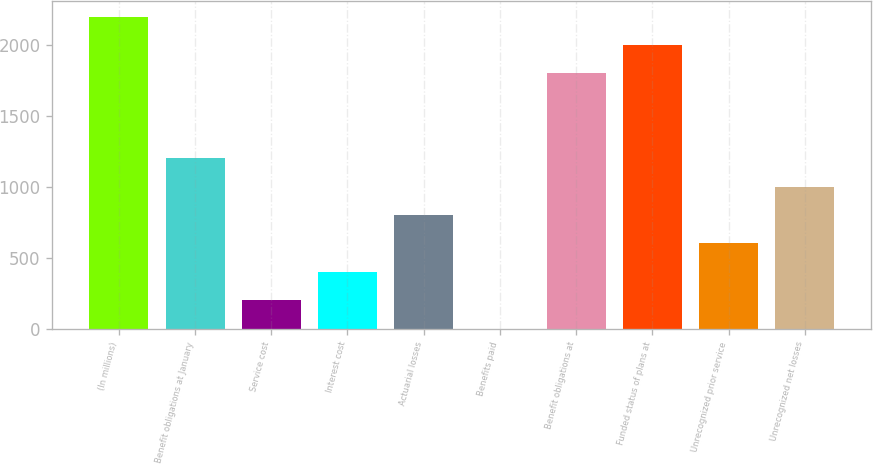<chart> <loc_0><loc_0><loc_500><loc_500><bar_chart><fcel>(In millions)<fcel>Benefit obligations at January<fcel>Service cost<fcel>Interest cost<fcel>Actuarial losses<fcel>Benefits paid<fcel>Benefit obligations at<fcel>Funded status of plans at<fcel>Unrecognized prior service<fcel>Unrecognized net losses<nl><fcel>2201.9<fcel>1202.4<fcel>202.9<fcel>402.8<fcel>802.6<fcel>3<fcel>1802.1<fcel>2002<fcel>602.7<fcel>1002.5<nl></chart> 